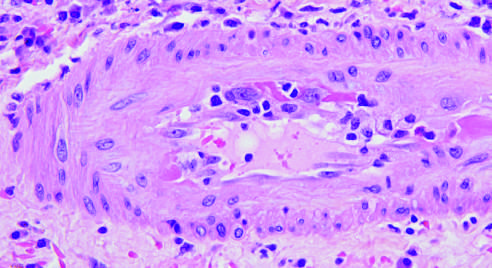what is shown with inflammatory cells attacking and undermining the endothelium?
Answer the question using a single word or phrase. An arteriole 